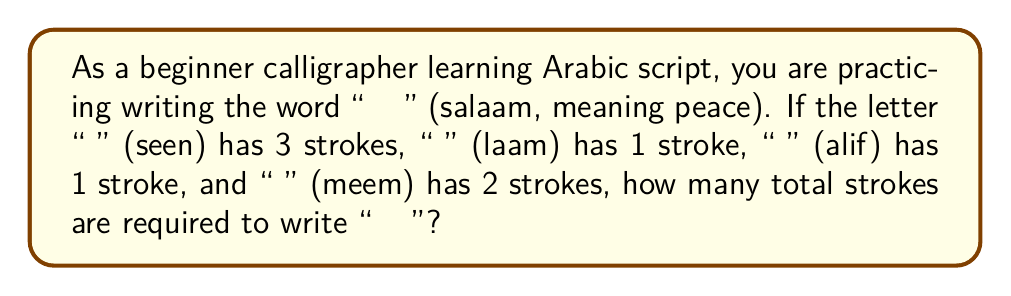Teach me how to tackle this problem. Let's break this down step-by-step:

1. Count the strokes for each letter:
   - "س" (seen): 3 strokes
   - "ل" (laam): 1 stroke
   - "ا" (alif): 1 stroke
   - "م" (meem): 2 strokes

2. Add up the strokes for all letters:
   $$ \text{Total strokes} = 3 + 1 + 1 + 2 $$

3. Perform the addition:
   $$ \text{Total strokes} = 7 $$

Therefore, writing "سلام" requires a total of 7 strokes.
Answer: 7 strokes 